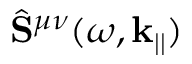<formula> <loc_0><loc_0><loc_500><loc_500>\hat { S } ^ { \mu \nu } ( \omega , k _ { | | } )</formula> 